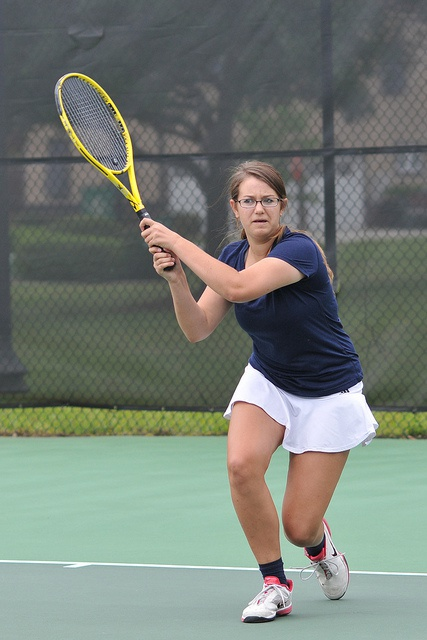Describe the objects in this image and their specific colors. I can see people in gray, black, lavender, and lightpink tones and tennis racket in gray, darkgray, and khaki tones in this image. 